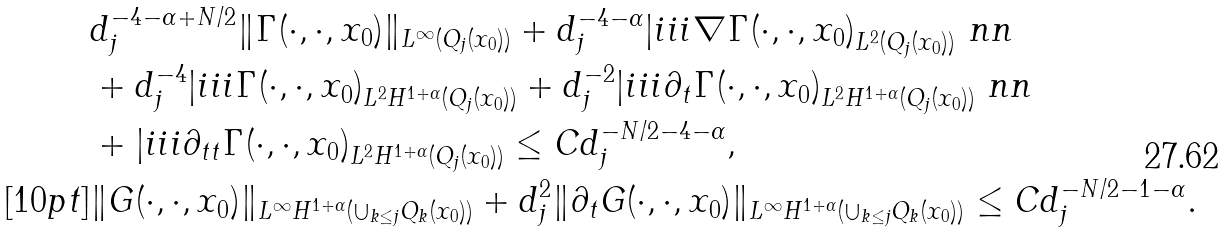<formula> <loc_0><loc_0><loc_500><loc_500>& d _ { j } ^ { - 4 - \alpha + N / 2 } \| \Gamma ( \cdot , \cdot , x _ { 0 } ) \| _ { L ^ { \infty } ( Q _ { j } ( x _ { 0 } ) ) } + d _ { j } ^ { - 4 - \alpha } | i i i { \nabla \Gamma ( \cdot , \cdot , x _ { 0 } ) } _ { L ^ { 2 } ( Q _ { j } ( x _ { 0 } ) ) } \ n n \\ & + d _ { j } ^ { - 4 } | i i i { \Gamma ( \cdot , \cdot , x _ { 0 } ) } _ { L ^ { 2 } H ^ { 1 + \alpha } ( Q _ { j } ( x _ { 0 } ) ) } + d _ { j } ^ { - 2 } | i i i { \partial _ { t } \Gamma ( \cdot , \cdot , x _ { 0 } ) } _ { L ^ { 2 } H ^ { 1 + \alpha } ( Q _ { j } ( x _ { 0 } ) ) } \ n n \\ & + | i i i { \partial _ { t t } \Gamma ( \cdot , \cdot , x _ { 0 } ) } _ { L ^ { 2 } H ^ { 1 + \alpha } ( Q _ { j } ( x _ { 0 } ) ) } \leq C d _ { j } ^ { - N / 2 - 4 - \alpha } , \\ [ 1 0 p t ] & \| G ( \cdot , \cdot , x _ { 0 } ) \| _ { L ^ { \infty } H ^ { 1 + \alpha } ( \cup _ { k \leq j } Q _ { k } ( x _ { 0 } ) ) } + d _ { j } ^ { 2 } \| \partial _ { t } G ( \cdot , \cdot , x _ { 0 } ) \| _ { L ^ { \infty } H ^ { 1 + \alpha } ( \cup _ { k \leq j } Q _ { k } ( x _ { 0 } ) ) } \leq C d _ { j } ^ { - N / 2 - 1 - \alpha } .</formula> 